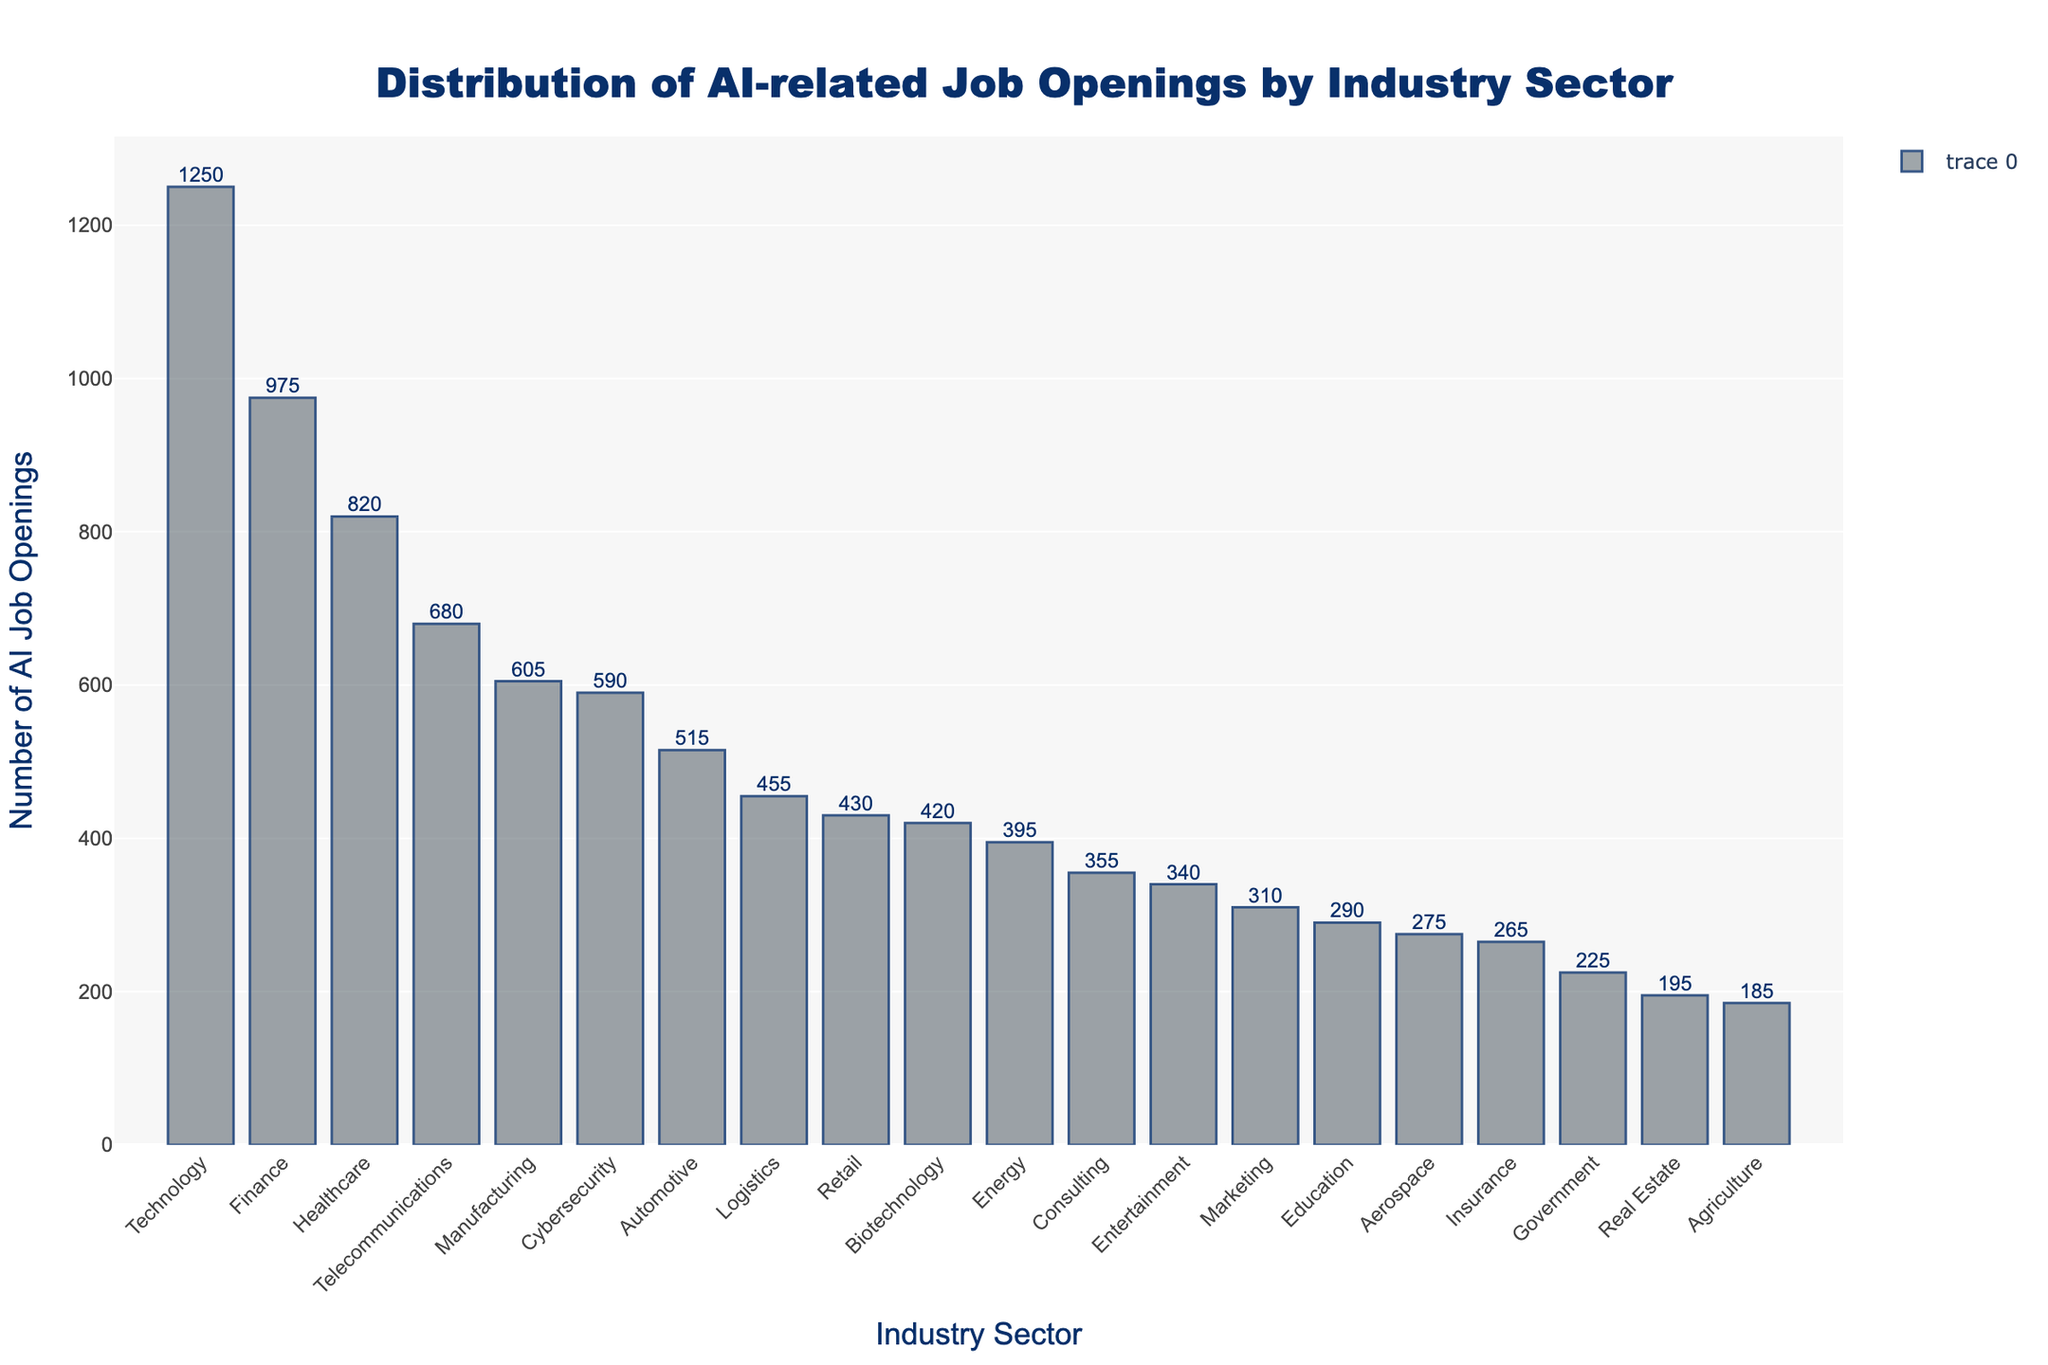Which industry sector has the highest number of AI job openings? The tallest bar on the chart represents the industry with the highest number of AI job openings. From the figure, the Technology sector has the tallest bar.
Answer: Technology What is the difference in the number of AI job openings between the Technology and Healthcare sectors? The number of AI job openings in Technology is 1250, and in Healthcare, it is 820. The difference is calculated as 1250 - 820.
Answer: 430 Are there more AI job openings in the Finance sector than in the Manufacturing sector? The Finance sector has 975 AI job openings, while the Manufacturing sector has 605. Comparing these, 975 is greater than 605.
Answer: Yes Which three industry sectors have the least number of AI job openings? The shortest bars on the chart indicate the sectors with the fewest job openings. Agriculture (185), Real Estate (195), and Government (225) have the shortest bars.
Answer: Agriculture, Real Estate, Government What's the sum of AI job openings in the Education, Automotive, and Telecommunications sectors? Add the number of AI job openings in Education (290), Automotive (515), and Telecommunications (680). The calculation is 290 + 515 + 680.
Answer: 1485 What is the average number of AI job openings across the top five sectors? First, identify the top five sectors: Technology (1250), Healthcare (820), Finance (975), Telecommunications (680), and Manufacturing (605). Sum these values and divide by 5. The calculation is (1250 + 820 + 975 + 680 + 605) / 5.
Answer: 866 Which sector has fewer AI job openings: Retail or Biotechnology? The chart shows Retail with 430 AI job openings and Biotechnology with 420. Comparing these, 420 is less than 430.
Answer: Biotechnology How many more AI job openings are there in the Technology sector compared to the Entertainment and Agriculture sectors combined? First, sum the AI job openings in Entertainment (340) and Agriculture (185), which is 340 + 185 = 525. Then, subtract this total from the AI job openings in Technology (1250). The calculation is 1250 - 525.
Answer: 725 What is the median number of AI job openings across all sectors? Sort the sectors by the number of AI job openings and find the middle value or the average of the two middle values. Here's the ordered list: 185, 195, 225, 265, 275, 290, 310, 340, 355, 395, 420, 430, 455, 515, 590, 605, 680, 820, 975, 1250. The median is the average of the 10th and 11th values: (395 + 420) / 2.
Answer: 407.5 Which industry sector has the most visually prominent bar, and what color is it? The most visually prominent (tallest) bar represents the sector with the highest job openings, which is the Technology sector. The bar color, as specified in the chart, is a shade of gray with a blue outline.
Answer: Technology, gray with blue outline 